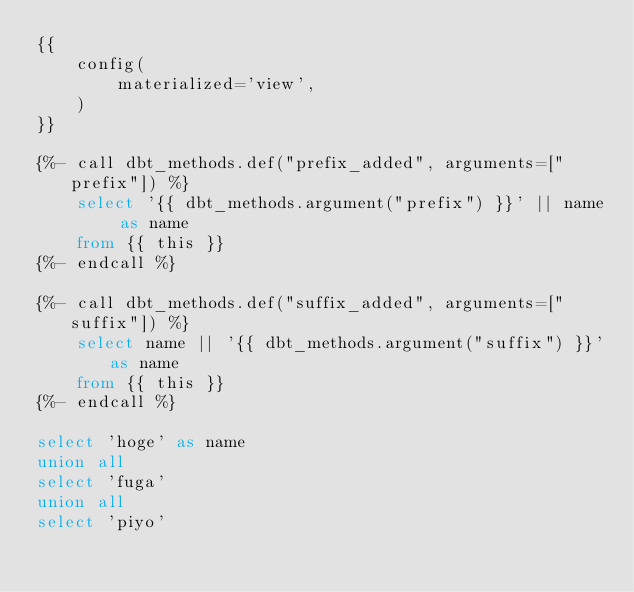Convert code to text. <code><loc_0><loc_0><loc_500><loc_500><_SQL_>{{
    config(
        materialized='view',
    )
}}

{%- call dbt_methods.def("prefix_added", arguments=["prefix"]) %}
    select '{{ dbt_methods.argument("prefix") }}' || name as name
    from {{ this }}
{%- endcall %}

{%- call dbt_methods.def("suffix_added", arguments=["suffix"]) %}
    select name || '{{ dbt_methods.argument("suffix") }}'as name
    from {{ this }}
{%- endcall %}

select 'hoge' as name
union all
select 'fuga'
union all
select 'piyo'
</code> 